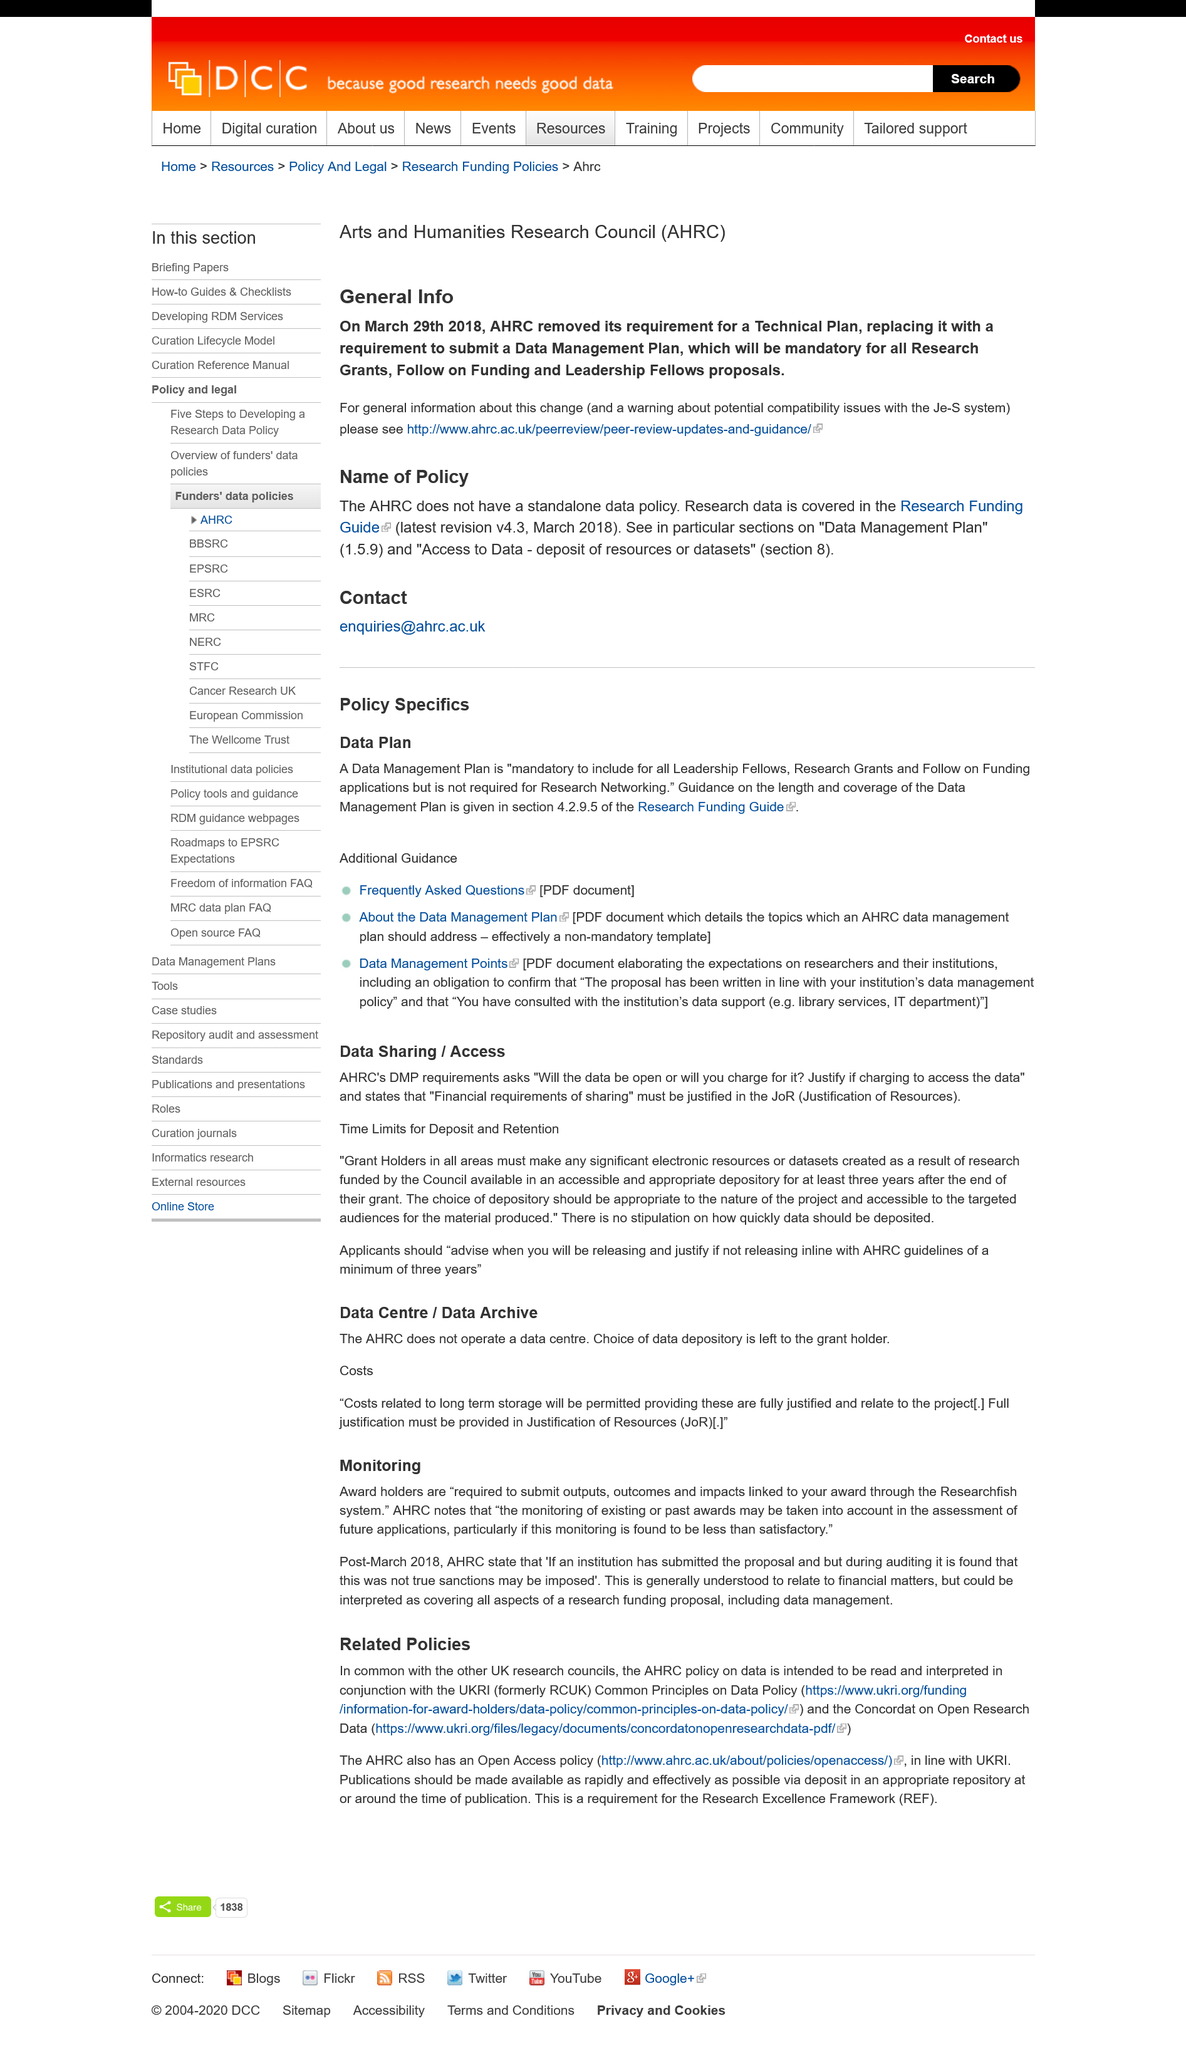Identify some key points in this picture. The AHRC does not have a standalone data policy. On March 29th, 2018, the AHRC removed its requirement for a Technical Plan. Research data is covered in the Research Funding Guide. 